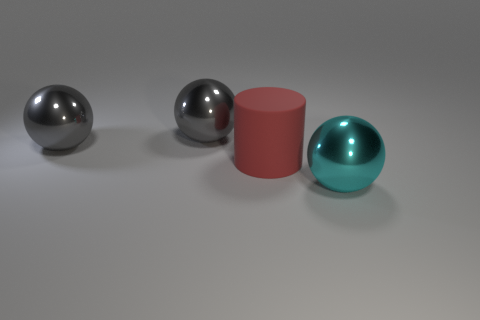Subtract all gray cubes. How many gray spheres are left? 2 Subtract all large gray balls. How many balls are left? 1 Add 1 green cubes. How many objects exist? 5 Subtract all cylinders. How many objects are left? 3 Subtract all blue spheres. Subtract all gray cylinders. How many spheres are left? 3 Subtract 1 cyan spheres. How many objects are left? 3 Subtract all large things. Subtract all tiny gray rubber balls. How many objects are left? 0 Add 4 red rubber cylinders. How many red rubber cylinders are left? 5 Add 4 gray shiny spheres. How many gray shiny spheres exist? 6 